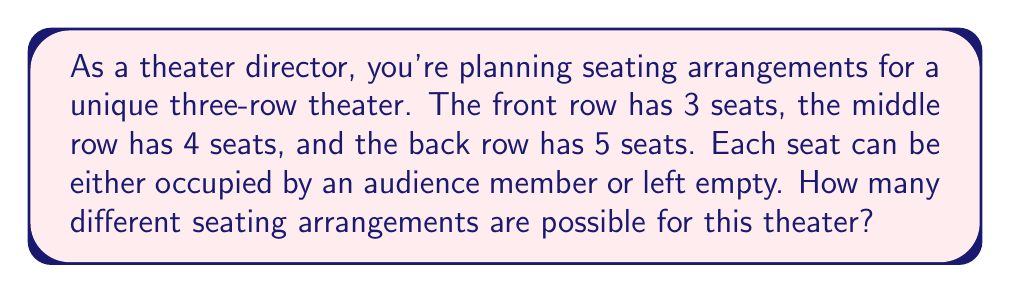Provide a solution to this math problem. Let's approach this problem using polynomial multiplication:

1) For each seat, we have two options: occupied (represented by x) or empty (represented by 1).

2) For the front row with 3 seats, we can represent the possibilities as:
   $$(x + 1)^3$$

3) For the middle row with 4 seats:
   $$(x + 1)^4$$

4) For the back row with 5 seats:
   $$(x + 1)^5$$

5) To find the total number of arrangements, we multiply these polynomials:
   $$P(x) = (x + 1)^3 * (x + 1)^4 * (x + 1)^5$$

6) This simplifies to:
   $$P(x) = (x + 1)^{12}$$

7) Expanding this using the binomial theorem:
   $$P(x) = \sum_{k=0}^{12} \binom{12}{k} x^k$$

8) The total number of arrangements is the sum of all coefficients, which is P(1):
   $$P(1) = \sum_{k=0}^{12} \binom{12}{k} = 2^{12}$$

9) Calculate:
   $$2^{12} = 4096$$

Thus, there are 4096 different seating arrangements possible.
Answer: 4096 